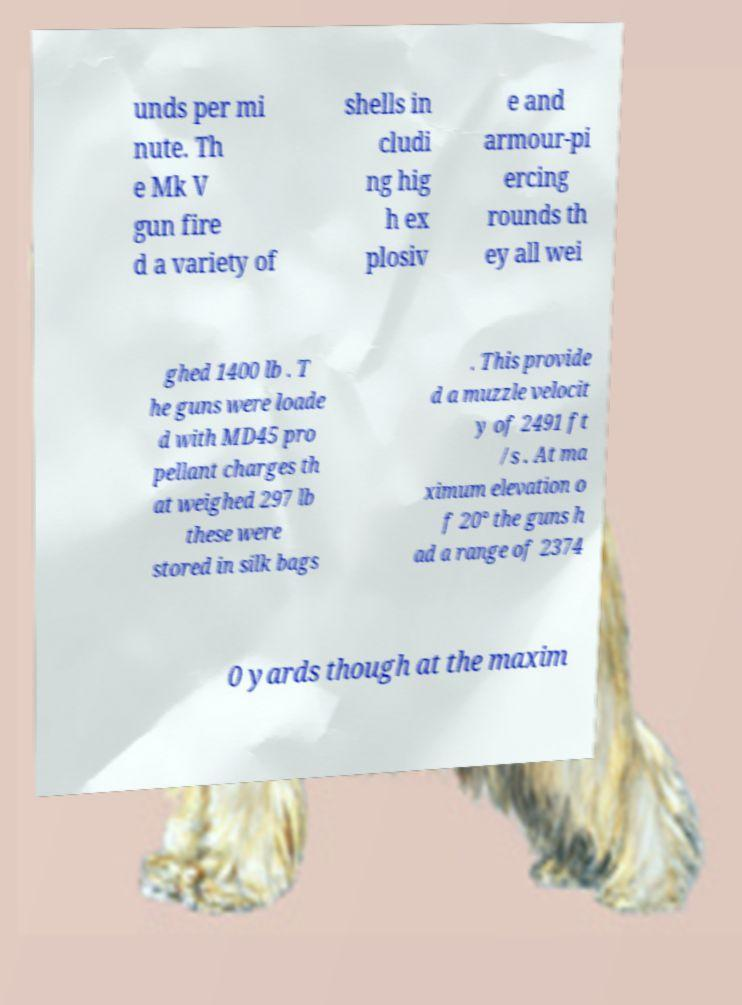Please read and relay the text visible in this image. What does it say? unds per mi nute. Th e Mk V gun fire d a variety of shells in cludi ng hig h ex plosiv e and armour-pi ercing rounds th ey all wei ghed 1400 lb . T he guns were loade d with MD45 pro pellant charges th at weighed 297 lb these were stored in silk bags . This provide d a muzzle velocit y of 2491 ft /s . At ma ximum elevation o f 20° the guns h ad a range of 2374 0 yards though at the maxim 